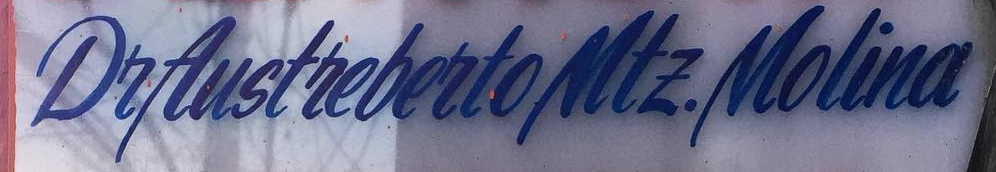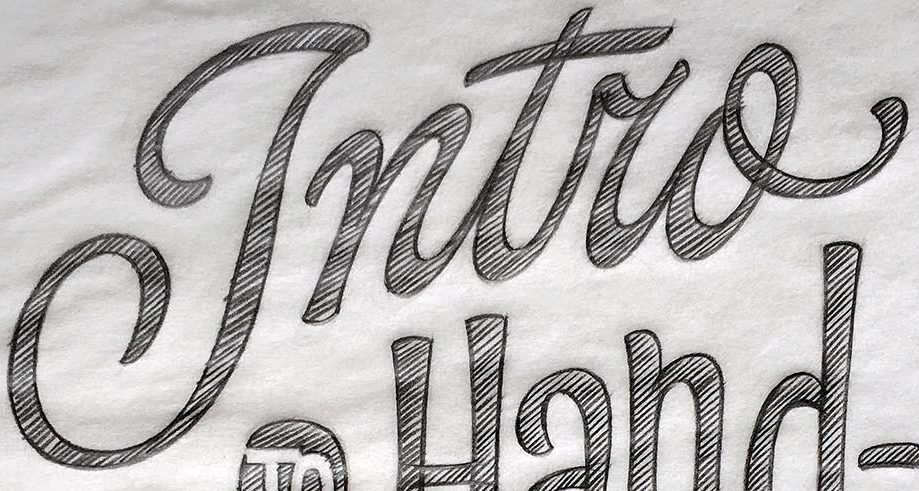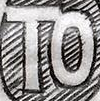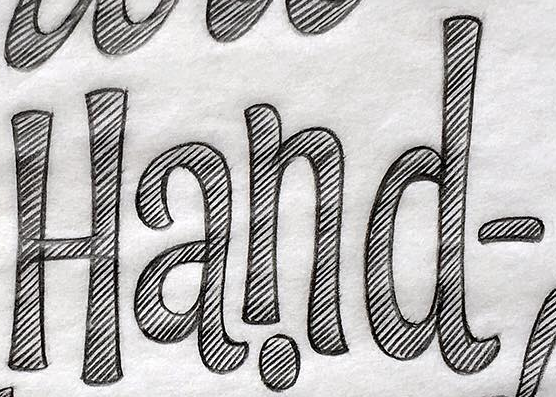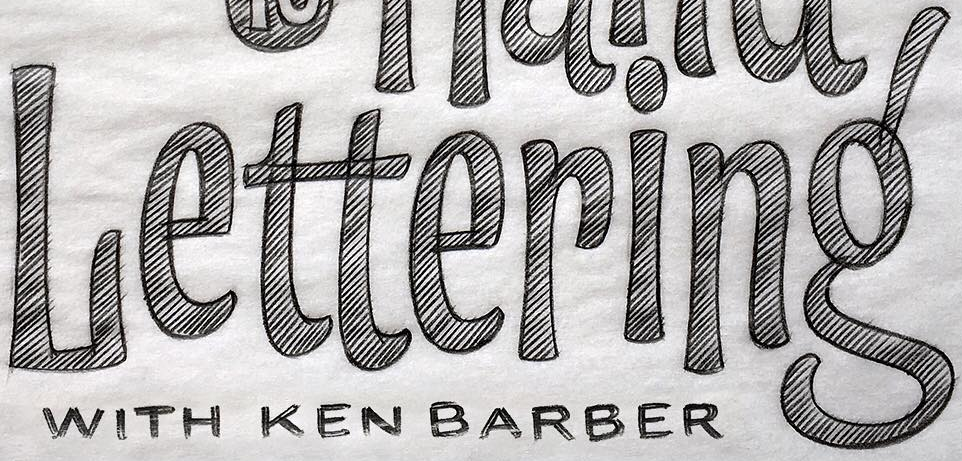Transcribe the words shown in these images in order, separated by a semicolon. DeAustrebertoMtE.Molina; Intro; TO; Hand-; Lettering' 